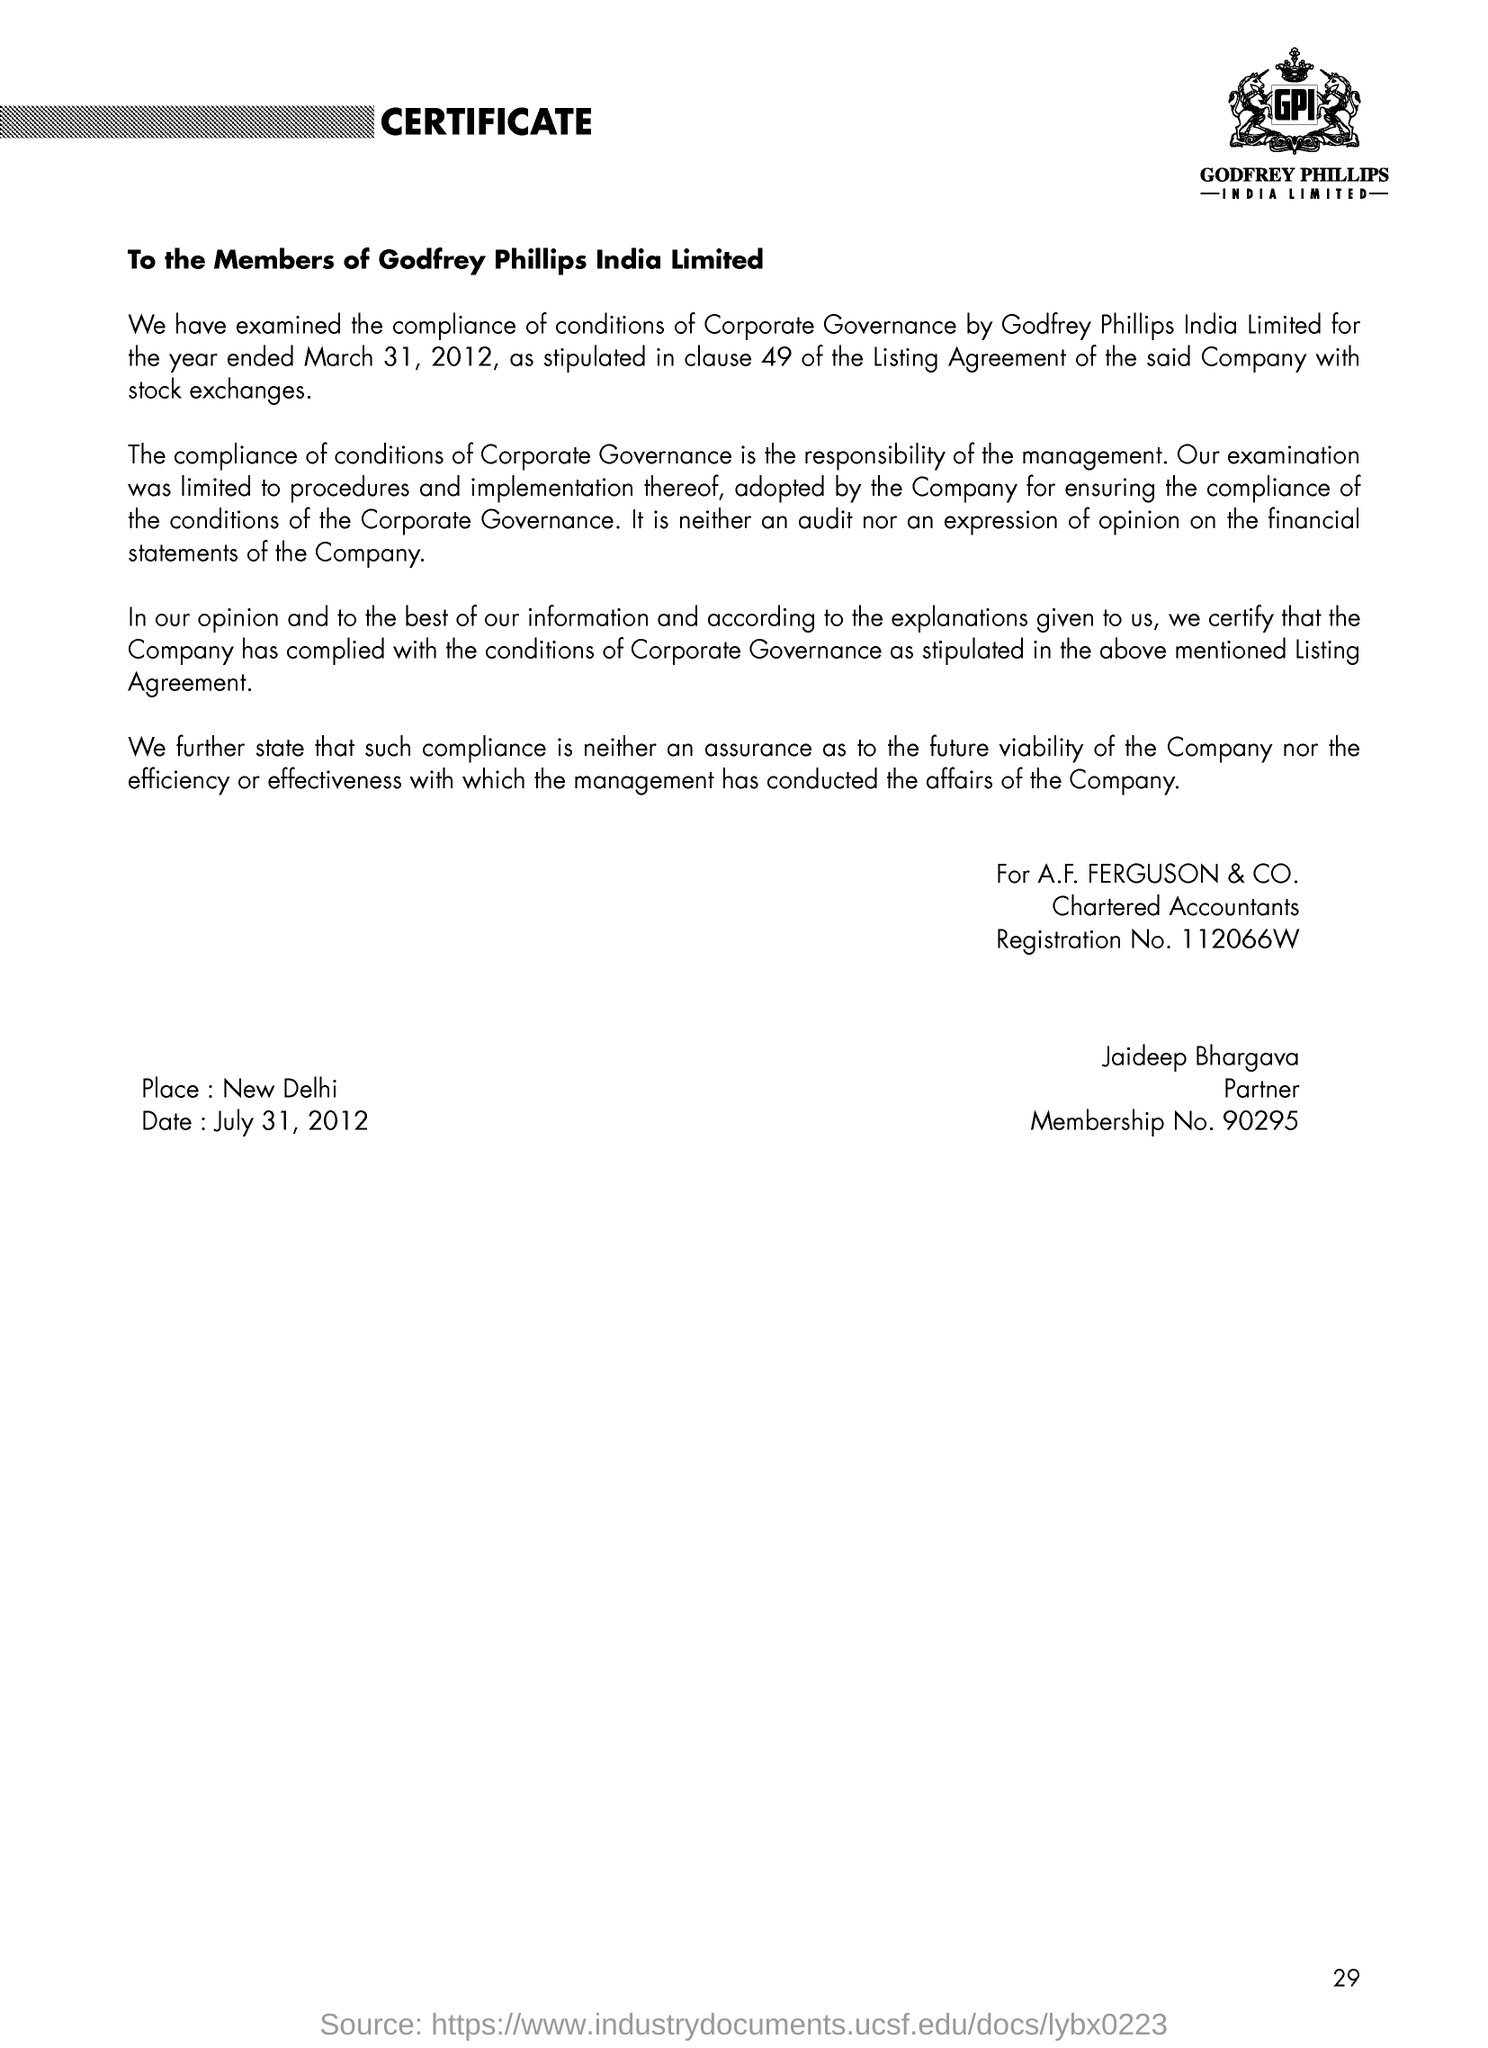Which company's name is at the top of the page?
Provide a short and direct response. GPI. To whom is the letter addressed?
Offer a very short reply. To the Members of Godfrey Phillips India Limited. Which is the place mentioned?
Your answer should be very brief. New Delhi. When is the letter dated?
Offer a very short reply. July 31, 2012. What is the Registration No. of the Chartered Accountants?
Provide a succinct answer. 112066W. What is the Membership No. of Jaideep Bhargava?
Keep it short and to the point. 90295. 